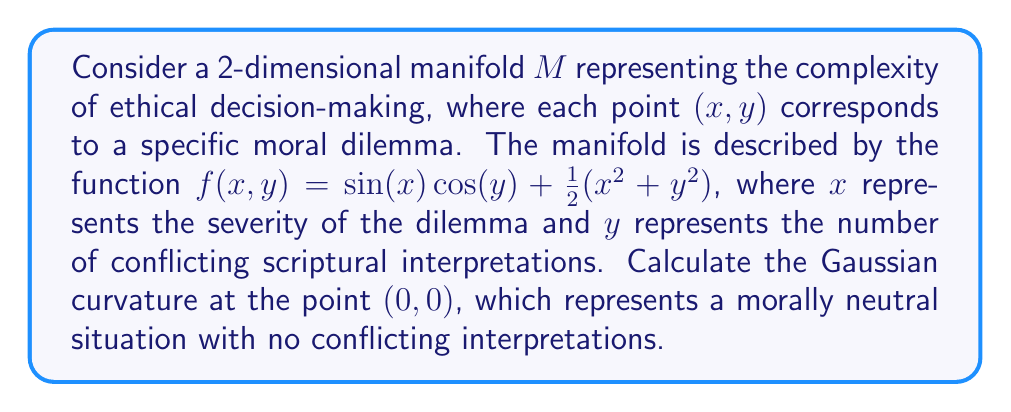Can you answer this question? To calculate the Gaussian curvature, we'll follow these steps:

1) The Gaussian curvature $K$ is given by:
   $$K = \frac{LN - M^2}{EG - F^2}$$
   where $L, M, N$ are the coefficients of the second fundamental form, and $E, F, G$ are the coefficients of the first fundamental form.

2) First, we need to calculate the partial derivatives:
   $$f_x = \cos(x)\cos(y) + x$$
   $$f_y = -\sin(x)\sin(y) + y$$
   $$f_{xx} = -\sin(x)\cos(y) + 1$$
   $$f_{yy} = -\sin(x)\cos(y) + 1$$
   $$f_{xy} = -\cos(x)\sin(y)$$

3) At $(0,0)$:
   $$f_x(0,0) = 1, f_y(0,0) = 0, f_{xx}(0,0) = 2, f_{yy}(0,0) = 2, f_{xy}(0,0) = 0$$

4) The coefficients of the first fundamental form are:
   $$E = 1 + f_x^2 = 2$$
   $$F = f_x f_y = 0$$
   $$G = 1 + f_y^2 = 1$$

5) The unit normal vector is:
   $$\vec{n} = \frac{(-f_x, -f_y, 1)}{\sqrt{1 + f_x^2 + f_y^2}} = (-\frac{1}{\sqrt{2}}, 0, \frac{1}{\sqrt{2}})$$

6) The coefficients of the second fundamental form are:
   $$L = \frac{f_{xx}}{\sqrt{1 + f_x^2 + f_y^2}} = \frac{2}{\sqrt{3}}$$
   $$M = \frac{f_{xy}}{\sqrt{1 + f_x^2 + f_y^2}} = 0$$
   $$N = \frac{f_{yy}}{\sqrt{1 + f_x^2 + f_y^2}} = \frac{2}{\sqrt{3}}$$

7) Now we can calculate the Gaussian curvature:
   $$K = \frac{LN - M^2}{EG - F^2} = \frac{(\frac{2}{\sqrt{3}})(\frac{2}{\sqrt{3}}) - 0^2}{(2)(1) - 0^2} = \frac{4/3}{2} = \frac{2}{3}$$

Therefore, the Gaussian curvature at $(0,0)$ is $\frac{2}{3}$.
Answer: $\frac{2}{3}$ 